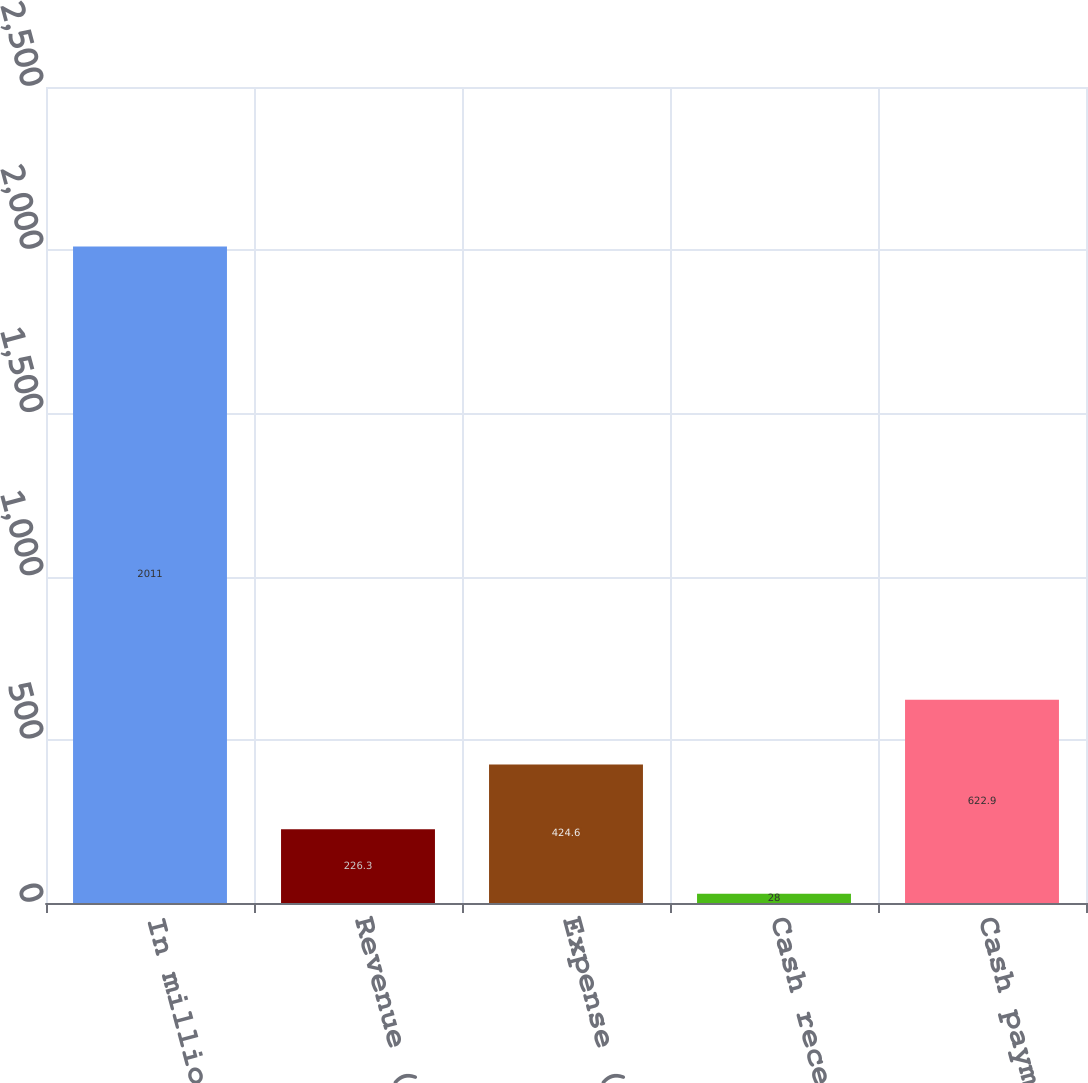<chart> <loc_0><loc_0><loc_500><loc_500><bar_chart><fcel>In millions<fcel>Revenue (loss) (a)<fcel>Expense (a)<fcel>Cash receipts (b)<fcel>Cash payments (c)<nl><fcel>2011<fcel>226.3<fcel>424.6<fcel>28<fcel>622.9<nl></chart> 